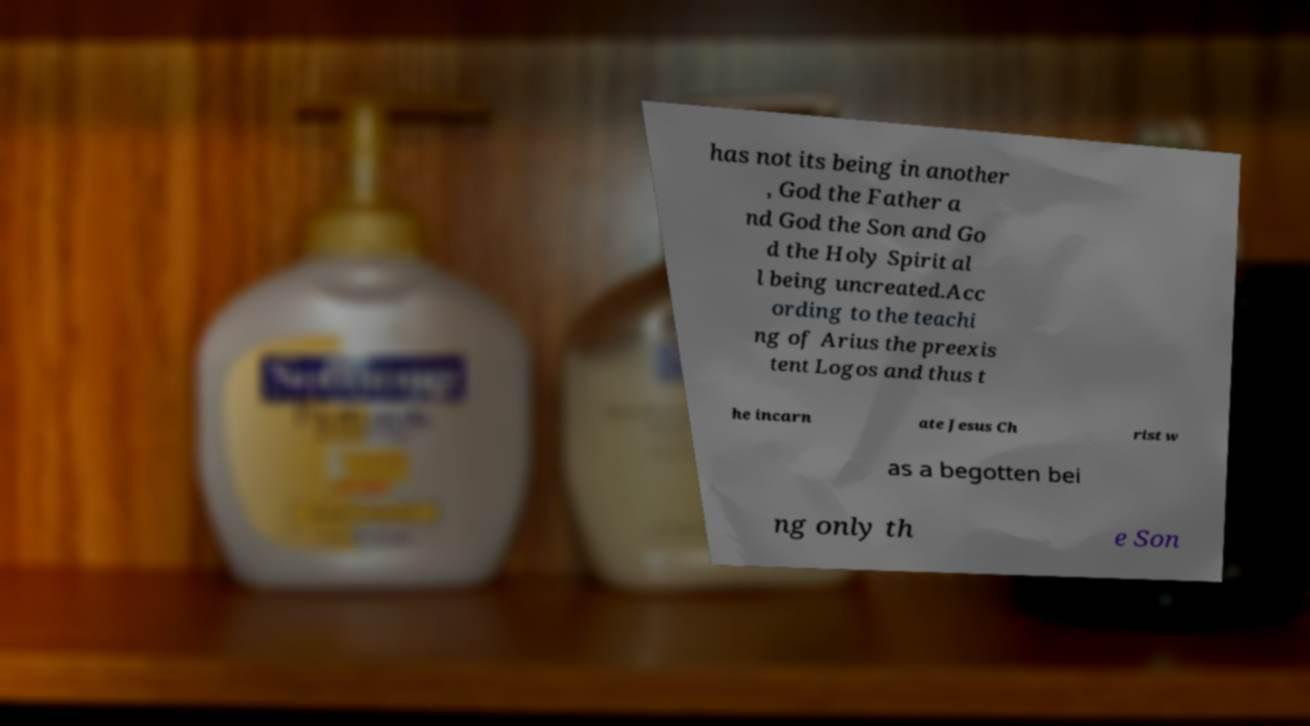I need the written content from this picture converted into text. Can you do that? has not its being in another , God the Father a nd God the Son and Go d the Holy Spirit al l being uncreated.Acc ording to the teachi ng of Arius the preexis tent Logos and thus t he incarn ate Jesus Ch rist w as a begotten bei ng only th e Son 